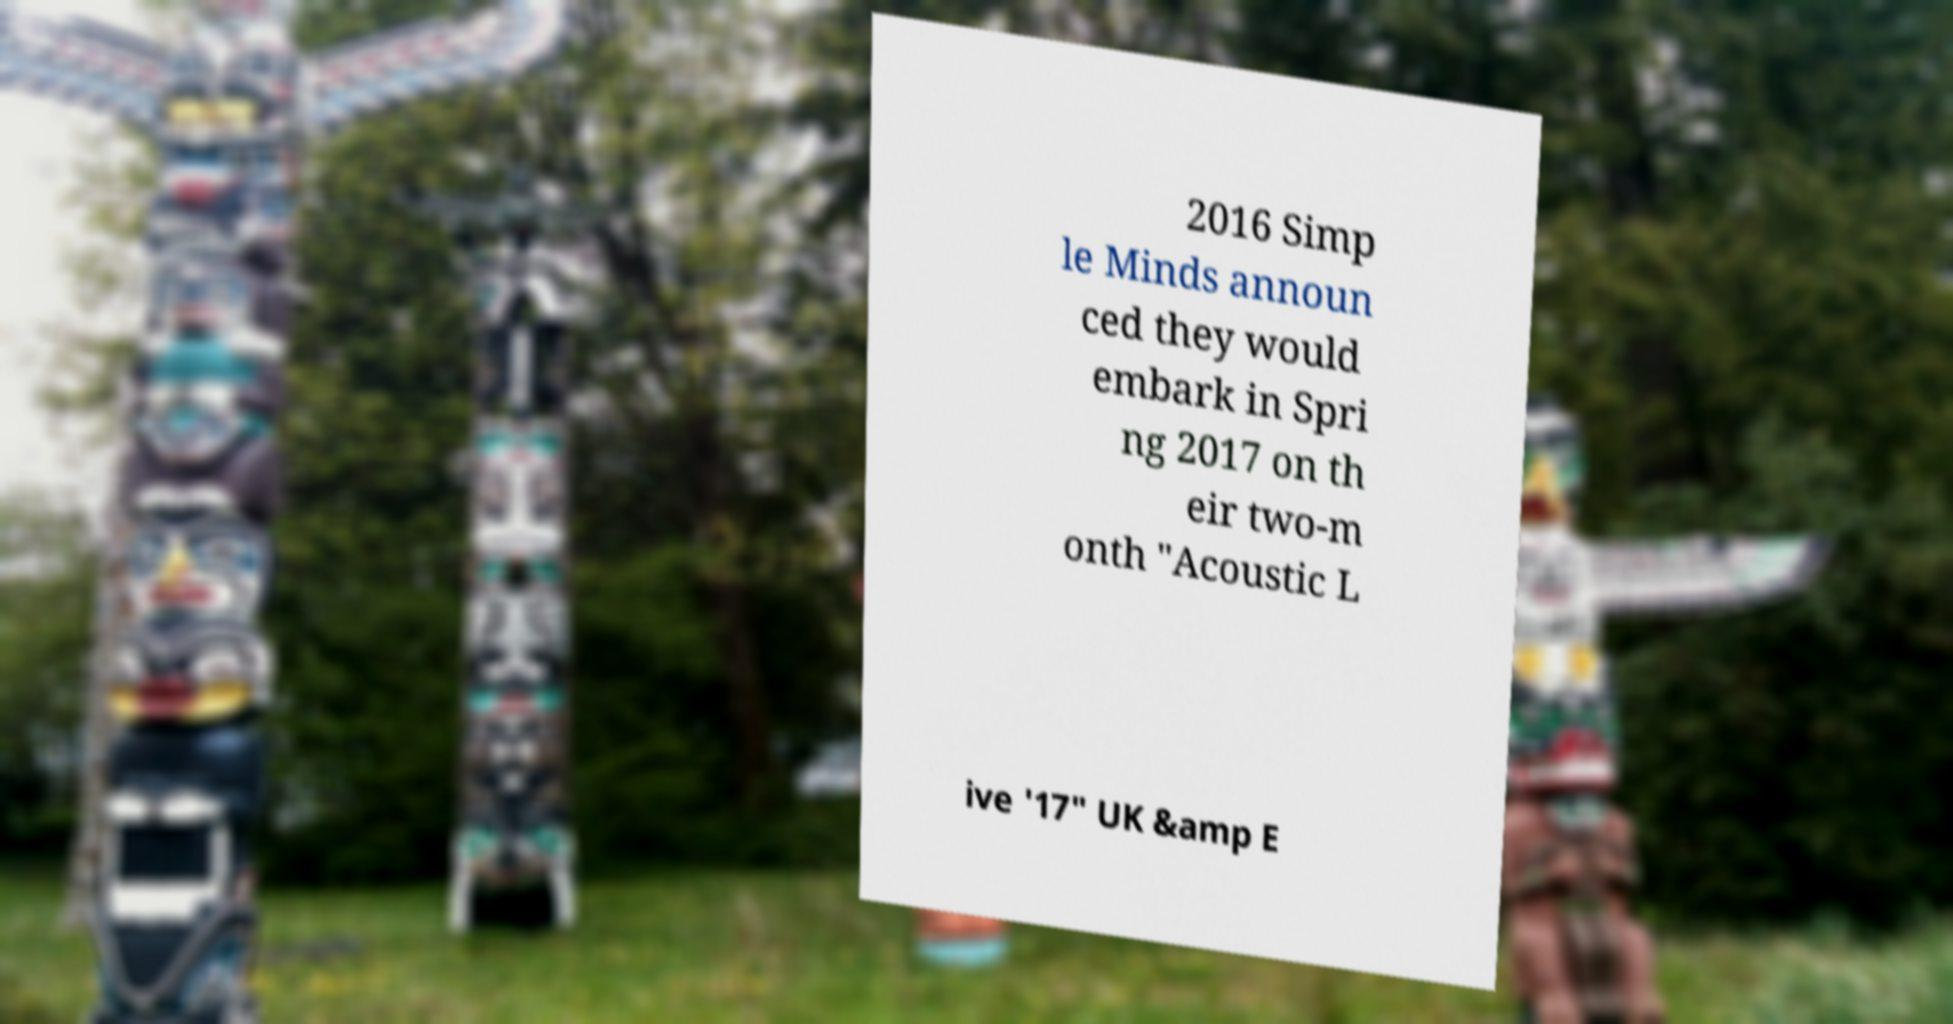I need the written content from this picture converted into text. Can you do that? 2016 Simp le Minds announ ced they would embark in Spri ng 2017 on th eir two-m onth "Acoustic L ive '17" UK &amp E 